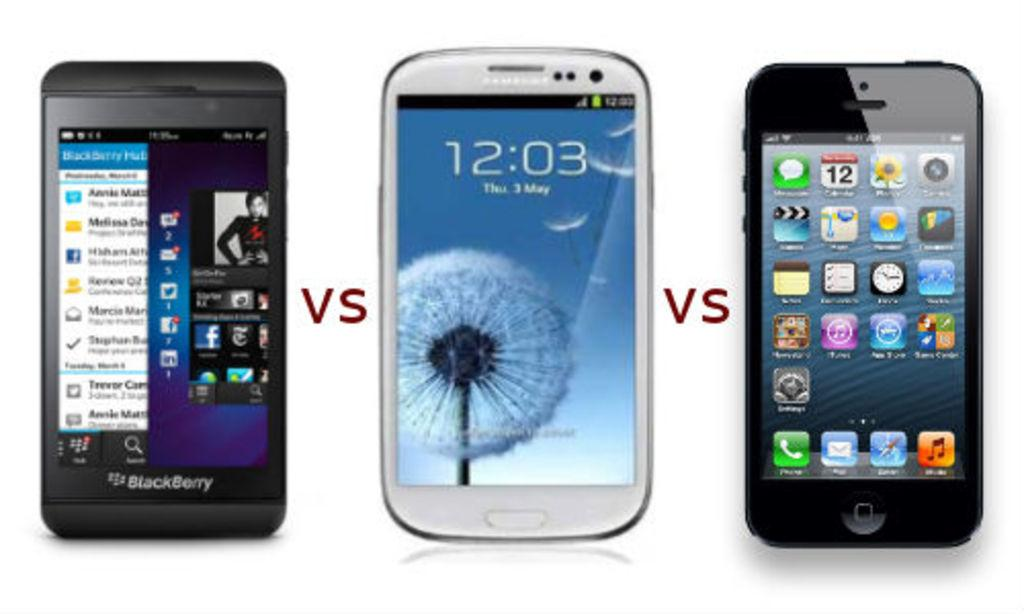<image>
Describe the image concisely. Three different brands of smart phones with VS between each of them. 